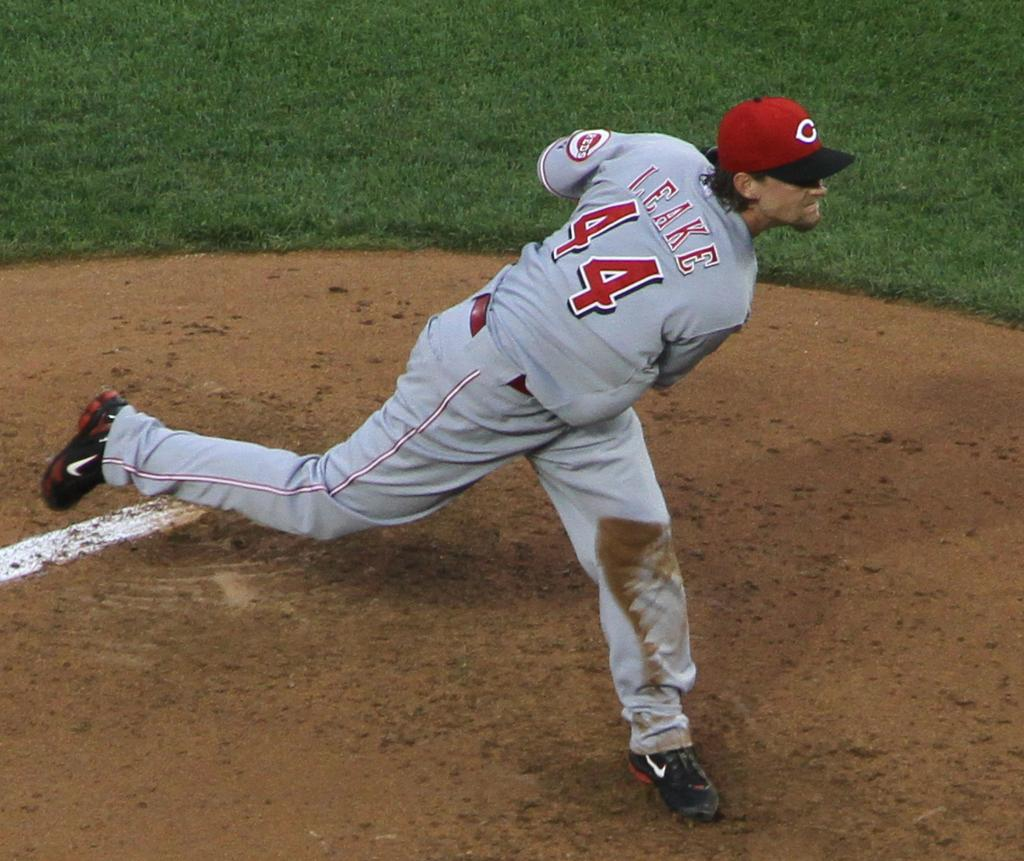<image>
Describe the image concisely. A baseball player has the number 44 on the back of his jersey. 